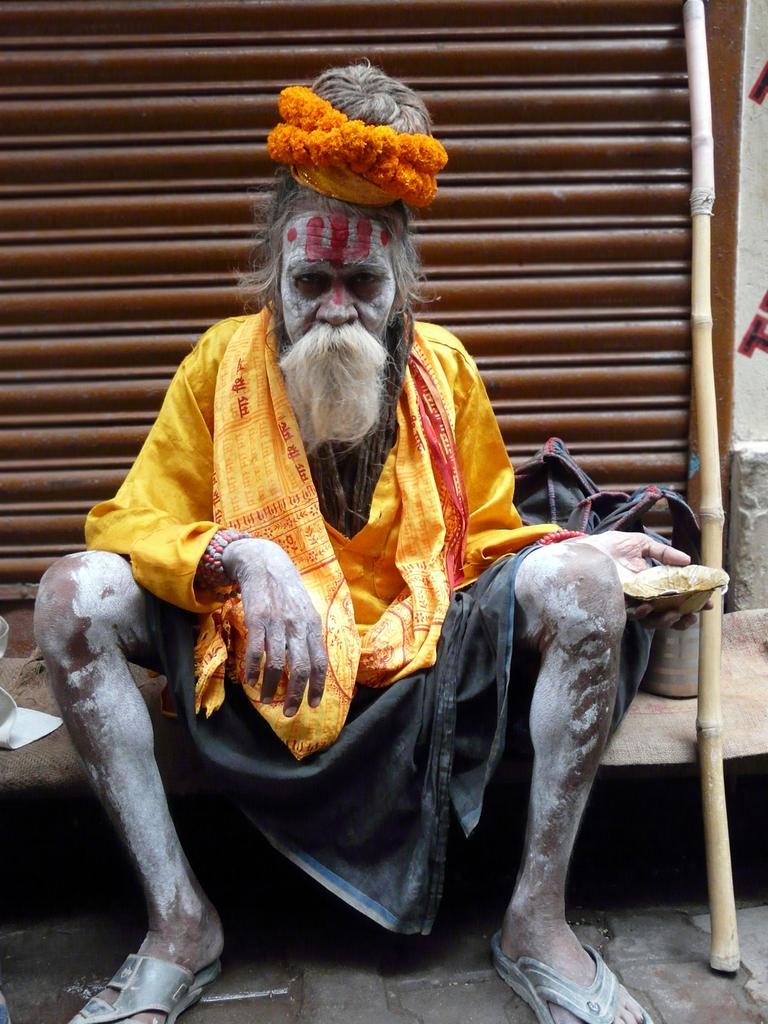What can be seen in the image? There is a person in the image. Can you describe the person's attire? The person is wearing a yellow and black color dress. What is the person holding in the image? The person is holding something, but we cannot determine what it is from the facts provided. Are there any other objects in the image besides the person? Yes, there are objects in the image. Can you describe any specific object in the image? There is a stick in the image. What is the color of the shutter in the image? There is a brown color shutter in the image. What type of invention can be seen in the hands of the maid in the image? There is no maid present in the image, and no invention can be seen in the hands of the person. 